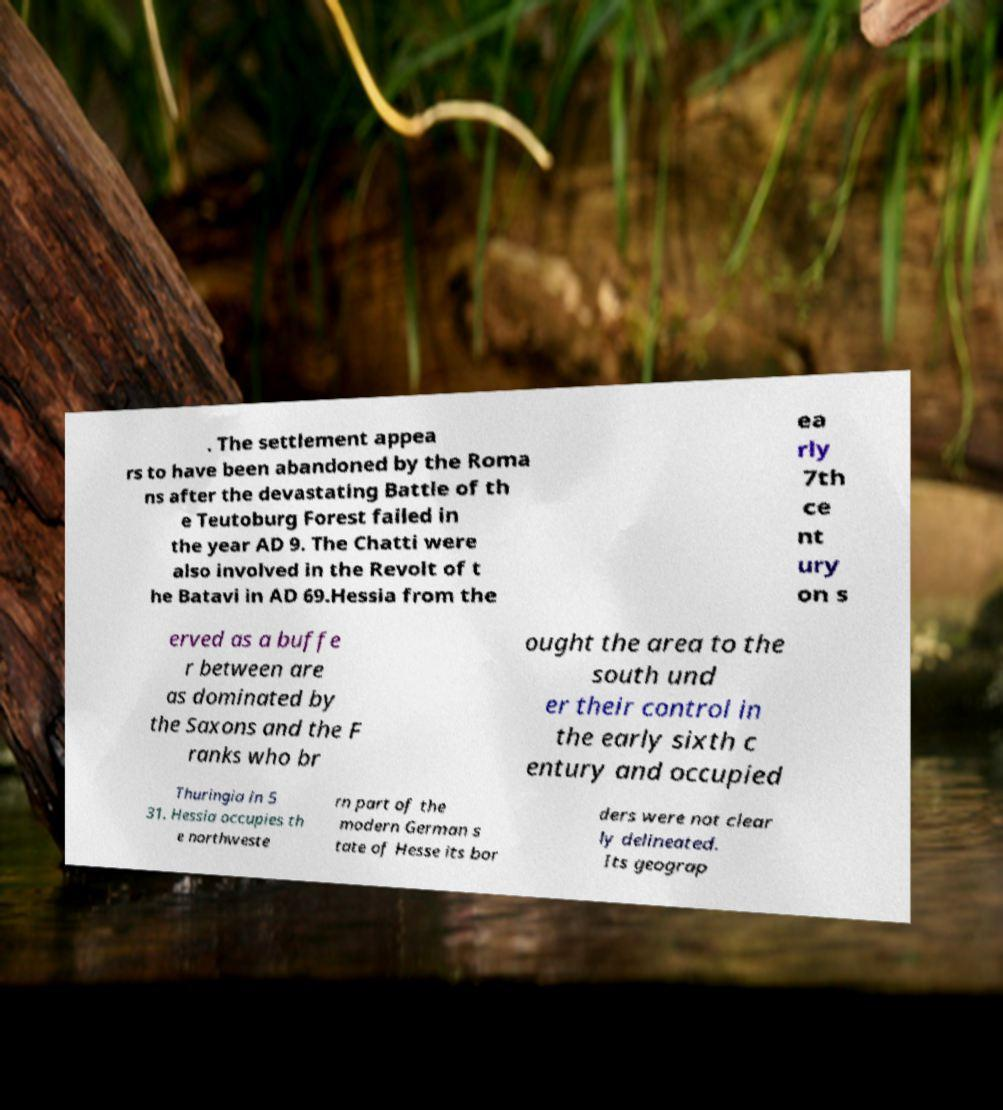Please read and relay the text visible in this image. What does it say? . The settlement appea rs to have been abandoned by the Roma ns after the devastating Battle of th e Teutoburg Forest failed in the year AD 9. The Chatti were also involved in the Revolt of t he Batavi in AD 69.Hessia from the ea rly 7th ce nt ury on s erved as a buffe r between are as dominated by the Saxons and the F ranks who br ought the area to the south und er their control in the early sixth c entury and occupied Thuringia in 5 31. Hessia occupies th e northweste rn part of the modern German s tate of Hesse its bor ders were not clear ly delineated. Its geograp 